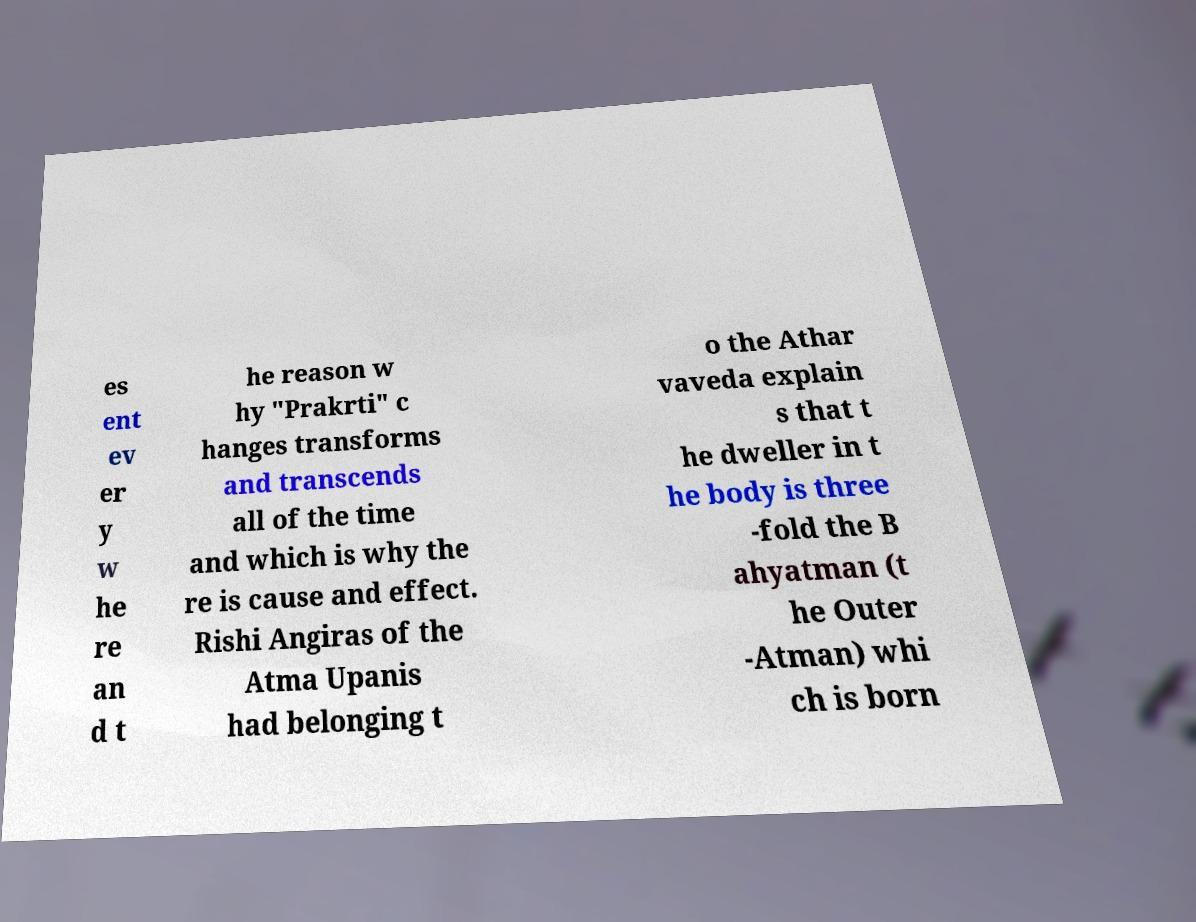Could you assist in decoding the text presented in this image and type it out clearly? es ent ev er y w he re an d t he reason w hy "Prakrti" c hanges transforms and transcends all of the time and which is why the re is cause and effect. Rishi Angiras of the Atma Upanis had belonging t o the Athar vaveda explain s that t he dweller in t he body is three -fold the B ahyatman (t he Outer -Atman) whi ch is born 